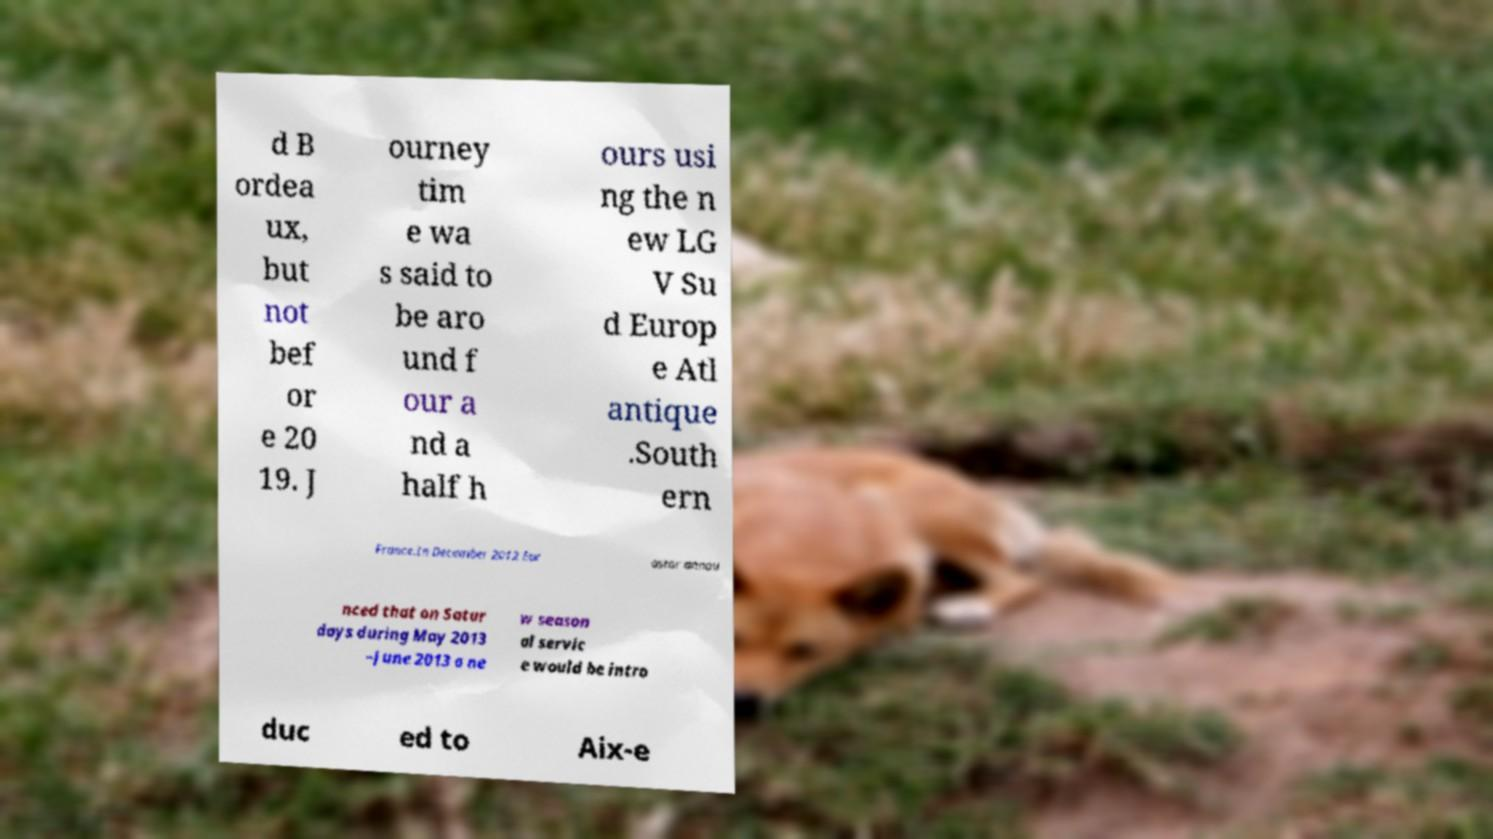For documentation purposes, I need the text within this image transcribed. Could you provide that? d B ordea ux, but not bef or e 20 19. J ourney tim e wa s said to be aro und f our a nd a half h ours usi ng the n ew LG V Su d Europ e Atl antique .South ern France.In December 2012 Eur ostar annou nced that on Satur days during May 2013 –June 2013 a ne w season al servic e would be intro duc ed to Aix-e 